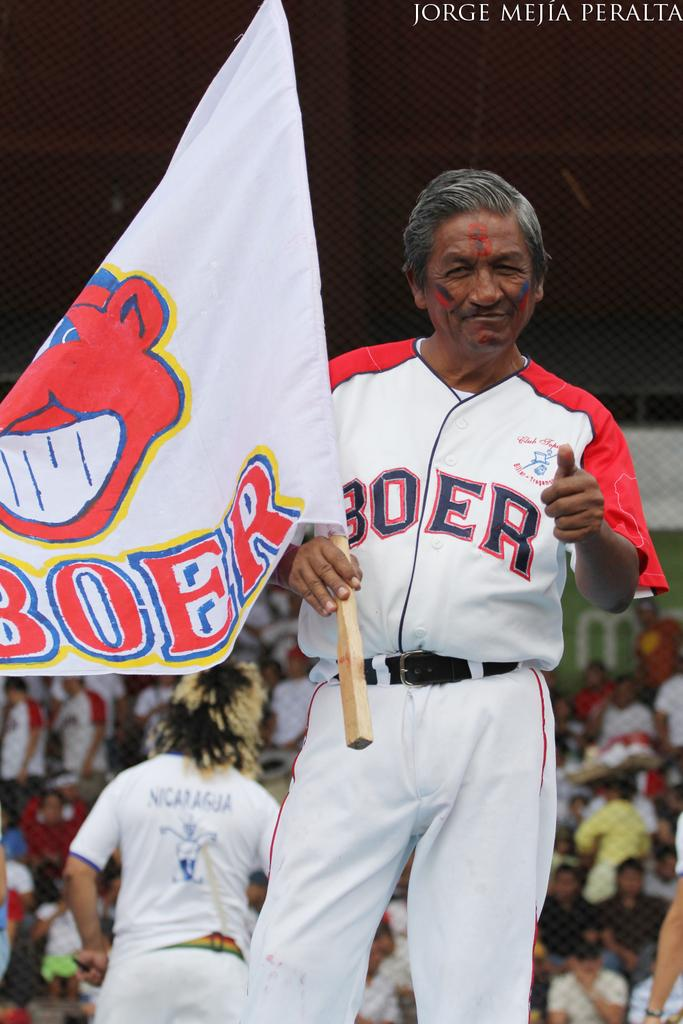<image>
Create a compact narrative representing the image presented. A man holds a BOER flag while pointing at the camera. 